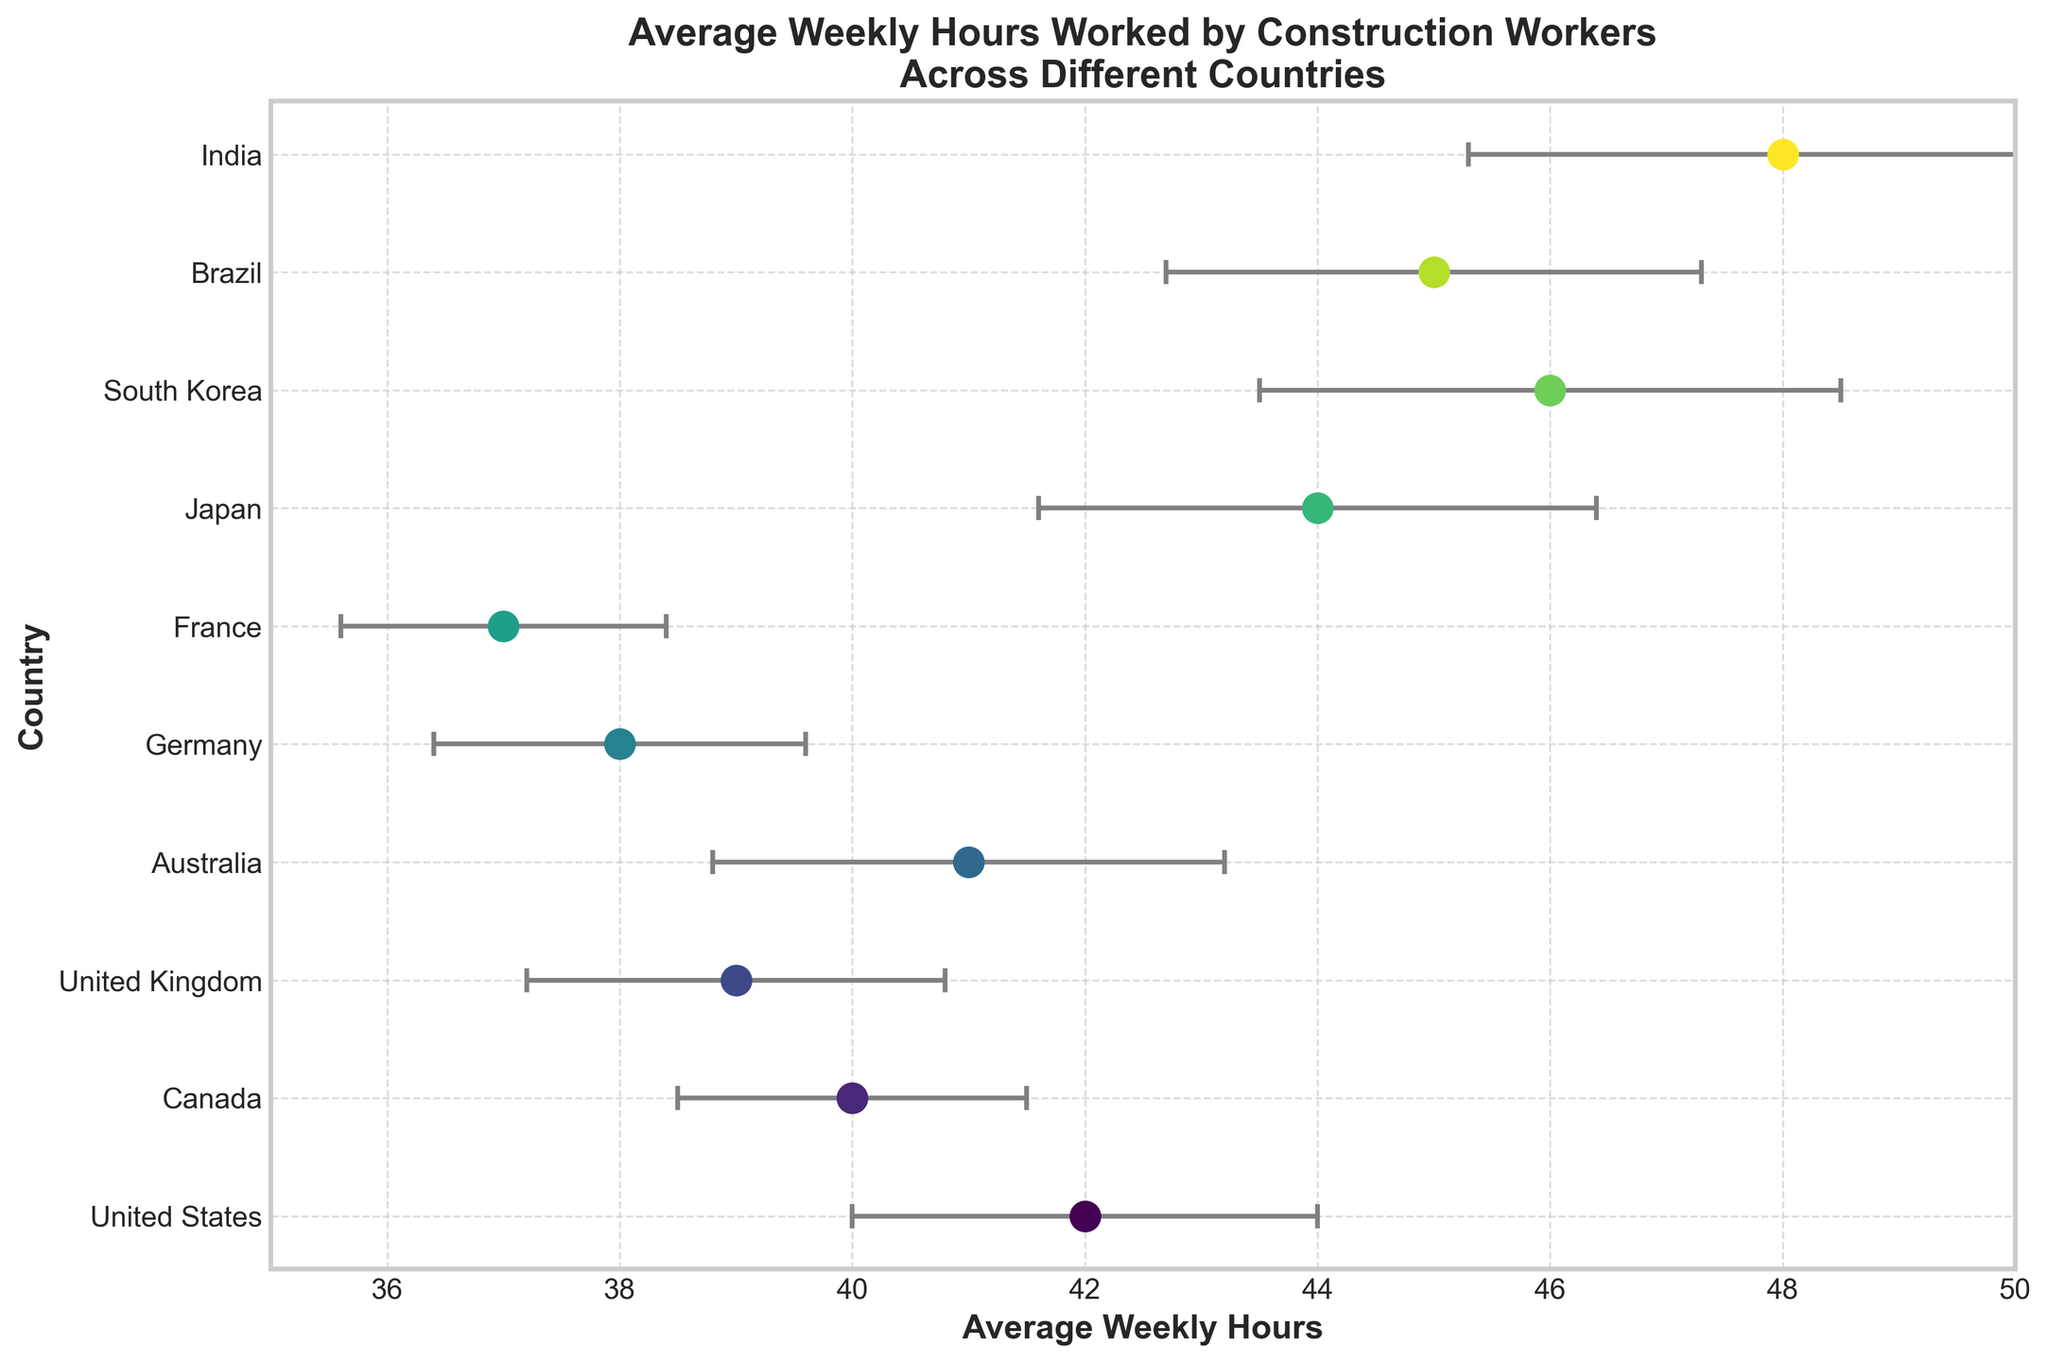How many countries are represented in the figure? Counting the distinct countries listed on the y-axis tells us how many countries are represented in the figure. After counting, the total number of countries is ten.
Answer: Ten What is the title of the figure? Observing the text at the top of the figure provides the title of the figure. The title reads 'Average Weekly Hours Worked by Construction Workers Across Different Countries.'
Answer: Average Weekly Hours Worked by Construction Workers Across Different Countries Which country has the highest average weekly hours worked? By locating the country that has the dot farthest to the right on the horizontal axis, which represents higher average hours, we find that India has the highest average weekly hours worked at 48 hours.
Answer: India What's the difference in average weekly hours between the United States and Japan? The United States has an average weekly hour of 42, while Japan has 44. Subtracting these values gives us the difference: 44 - 42.
Answer: 2 Which country has the smallest error margin in their average weekly hours worked? By examining the error bars and finding the shortest one, we see that France has the smallest error margin of 1.4.
Answer: France How many countries have an average weekly hour less than 40? By identifying the dots positioned to the left of the 40-hour mark on the x-axis and counting them, we see that Germany and France have an average less than 40 hours.
Answer: Two Which countries have an overlapping error margin with Australia's average weekly hours? Australia's average weekly hours are 41 with an error margin of ±2.2, giving a range of 38.8 to 43.2. The countries with overlapping ranges are the United States (40-44), Canada (38.5-41.5), and the United Kingdom (37.2-40.8).
Answer: The United States, Canada, the United Kingdom What is the average of the highest and lowest average weekly hours among the countries? The highest average weekly hours are 48 (India), and the lowest is 37 (France). The average of these values is calculated as (48 + 37) / 2.
Answer: 42.5 How does the average weekly hours worked by construction workers in the United Kingdom compare to those in Japan? The United Kingdom has an average of 39 hours, while Japan has 44 hours. Japan's workers have higher average weekly hours worked compared to those in the United Kingdom by 5 hours.
Answer: Japan's higher by 5 hours 